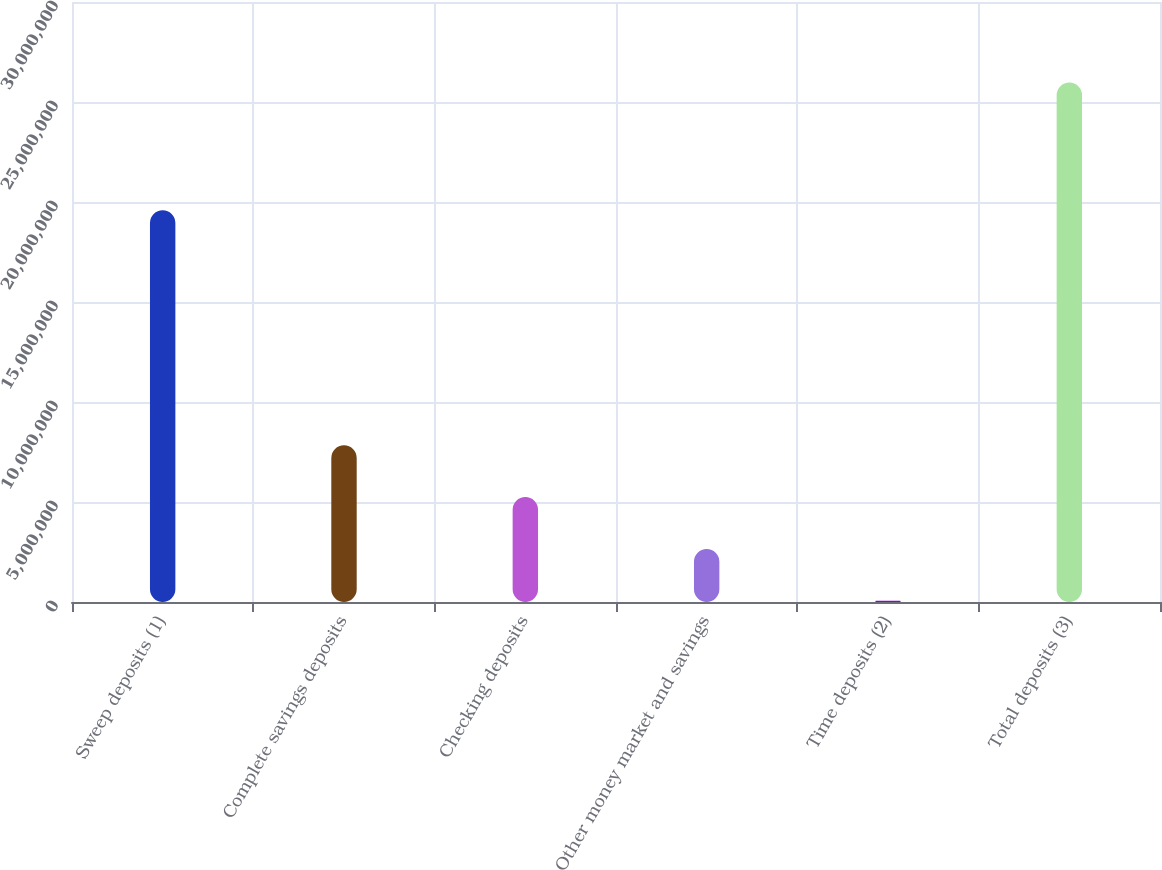<chart> <loc_0><loc_0><loc_500><loc_500><bar_chart><fcel>Sweep deposits (1)<fcel>Complete savings deposits<fcel>Checking deposits<fcel>Other money market and savings<fcel>Time deposits (2)<fcel>Total deposits (3)<nl><fcel>1.95921e+07<fcel>7.83588e+06<fcel>5.24517e+06<fcel>2.65446e+06<fcel>63748<fcel>2.59708e+07<nl></chart> 